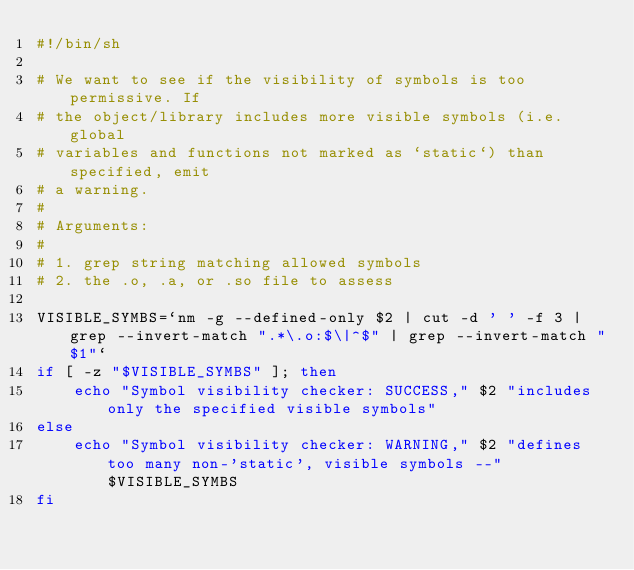<code> <loc_0><loc_0><loc_500><loc_500><_Bash_>#!/bin/sh

# We want to see if the visibility of symbols is too permissive. If
# the object/library includes more visible symbols (i.e. global
# variables and functions not marked as `static`) than specified, emit
# a warning.
#
# Arguments:
#
# 1. grep string matching allowed symbols
# 2. the .o, .a, or .so file to assess

VISIBLE_SYMBS=`nm -g --defined-only $2 | cut -d ' ' -f 3 | grep --invert-match ".*\.o:$\|^$" | grep --invert-match "$1"`
if [ -z "$VISIBLE_SYMBS" ]; then
    echo "Symbol visibility checker: SUCCESS," $2 "includes only the specified visible symbols"
else
    echo "Symbol visibility checker: WARNING," $2 "defines too many non-'static', visible symbols --" $VISIBLE_SYMBS
fi
</code> 